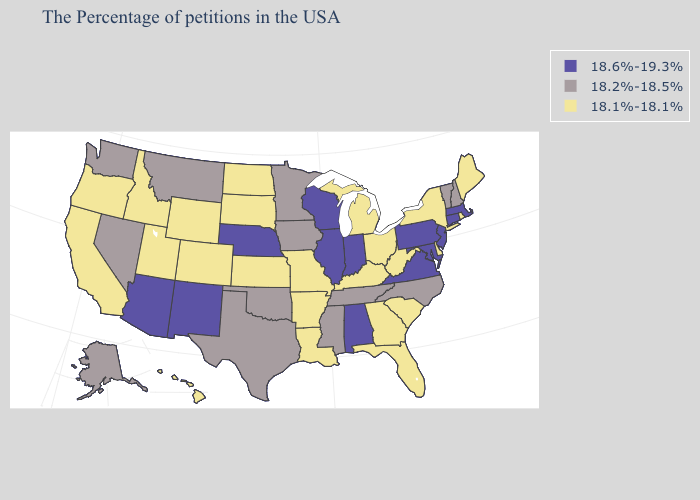What is the lowest value in the MidWest?
Keep it brief. 18.1%-18.1%. Name the states that have a value in the range 18.2%-18.5%?
Short answer required. New Hampshire, Vermont, North Carolina, Tennessee, Mississippi, Minnesota, Iowa, Oklahoma, Texas, Montana, Nevada, Washington, Alaska. What is the highest value in the MidWest ?
Answer briefly. 18.6%-19.3%. Does Colorado have a lower value than Connecticut?
Concise answer only. Yes. What is the value of Colorado?
Short answer required. 18.1%-18.1%. Name the states that have a value in the range 18.6%-19.3%?
Quick response, please. Massachusetts, Connecticut, New Jersey, Maryland, Pennsylvania, Virginia, Indiana, Alabama, Wisconsin, Illinois, Nebraska, New Mexico, Arizona. Does the map have missing data?
Keep it brief. No. Does Oklahoma have the lowest value in the South?
Keep it brief. No. What is the value of New Mexico?
Write a very short answer. 18.6%-19.3%. How many symbols are there in the legend?
Give a very brief answer. 3. What is the value of Mississippi?
Short answer required. 18.2%-18.5%. Name the states that have a value in the range 18.1%-18.1%?
Quick response, please. Maine, Rhode Island, New York, Delaware, South Carolina, West Virginia, Ohio, Florida, Georgia, Michigan, Kentucky, Louisiana, Missouri, Arkansas, Kansas, South Dakota, North Dakota, Wyoming, Colorado, Utah, Idaho, California, Oregon, Hawaii. Which states have the lowest value in the USA?
Quick response, please. Maine, Rhode Island, New York, Delaware, South Carolina, West Virginia, Ohio, Florida, Georgia, Michigan, Kentucky, Louisiana, Missouri, Arkansas, Kansas, South Dakota, North Dakota, Wyoming, Colorado, Utah, Idaho, California, Oregon, Hawaii. Name the states that have a value in the range 18.2%-18.5%?
Answer briefly. New Hampshire, Vermont, North Carolina, Tennessee, Mississippi, Minnesota, Iowa, Oklahoma, Texas, Montana, Nevada, Washington, Alaska. Does New Mexico have the same value as Arizona?
Write a very short answer. Yes. 